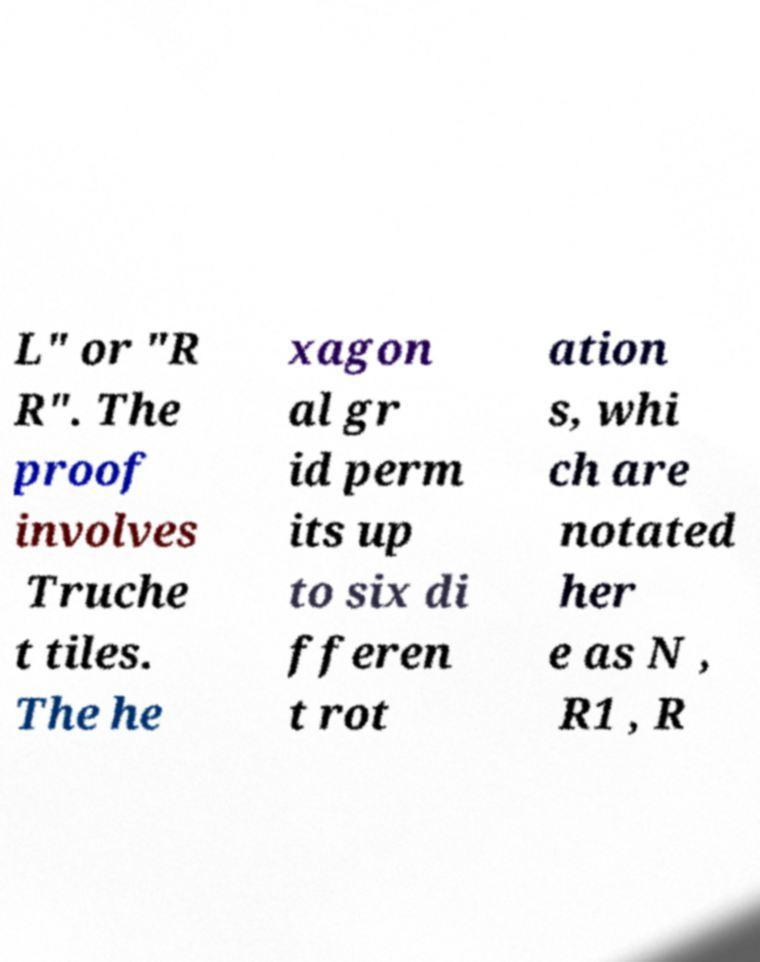I need the written content from this picture converted into text. Can you do that? L" or "R R". The proof involves Truche t tiles. The he xagon al gr id perm its up to six di fferen t rot ation s, whi ch are notated her e as N , R1 , R 